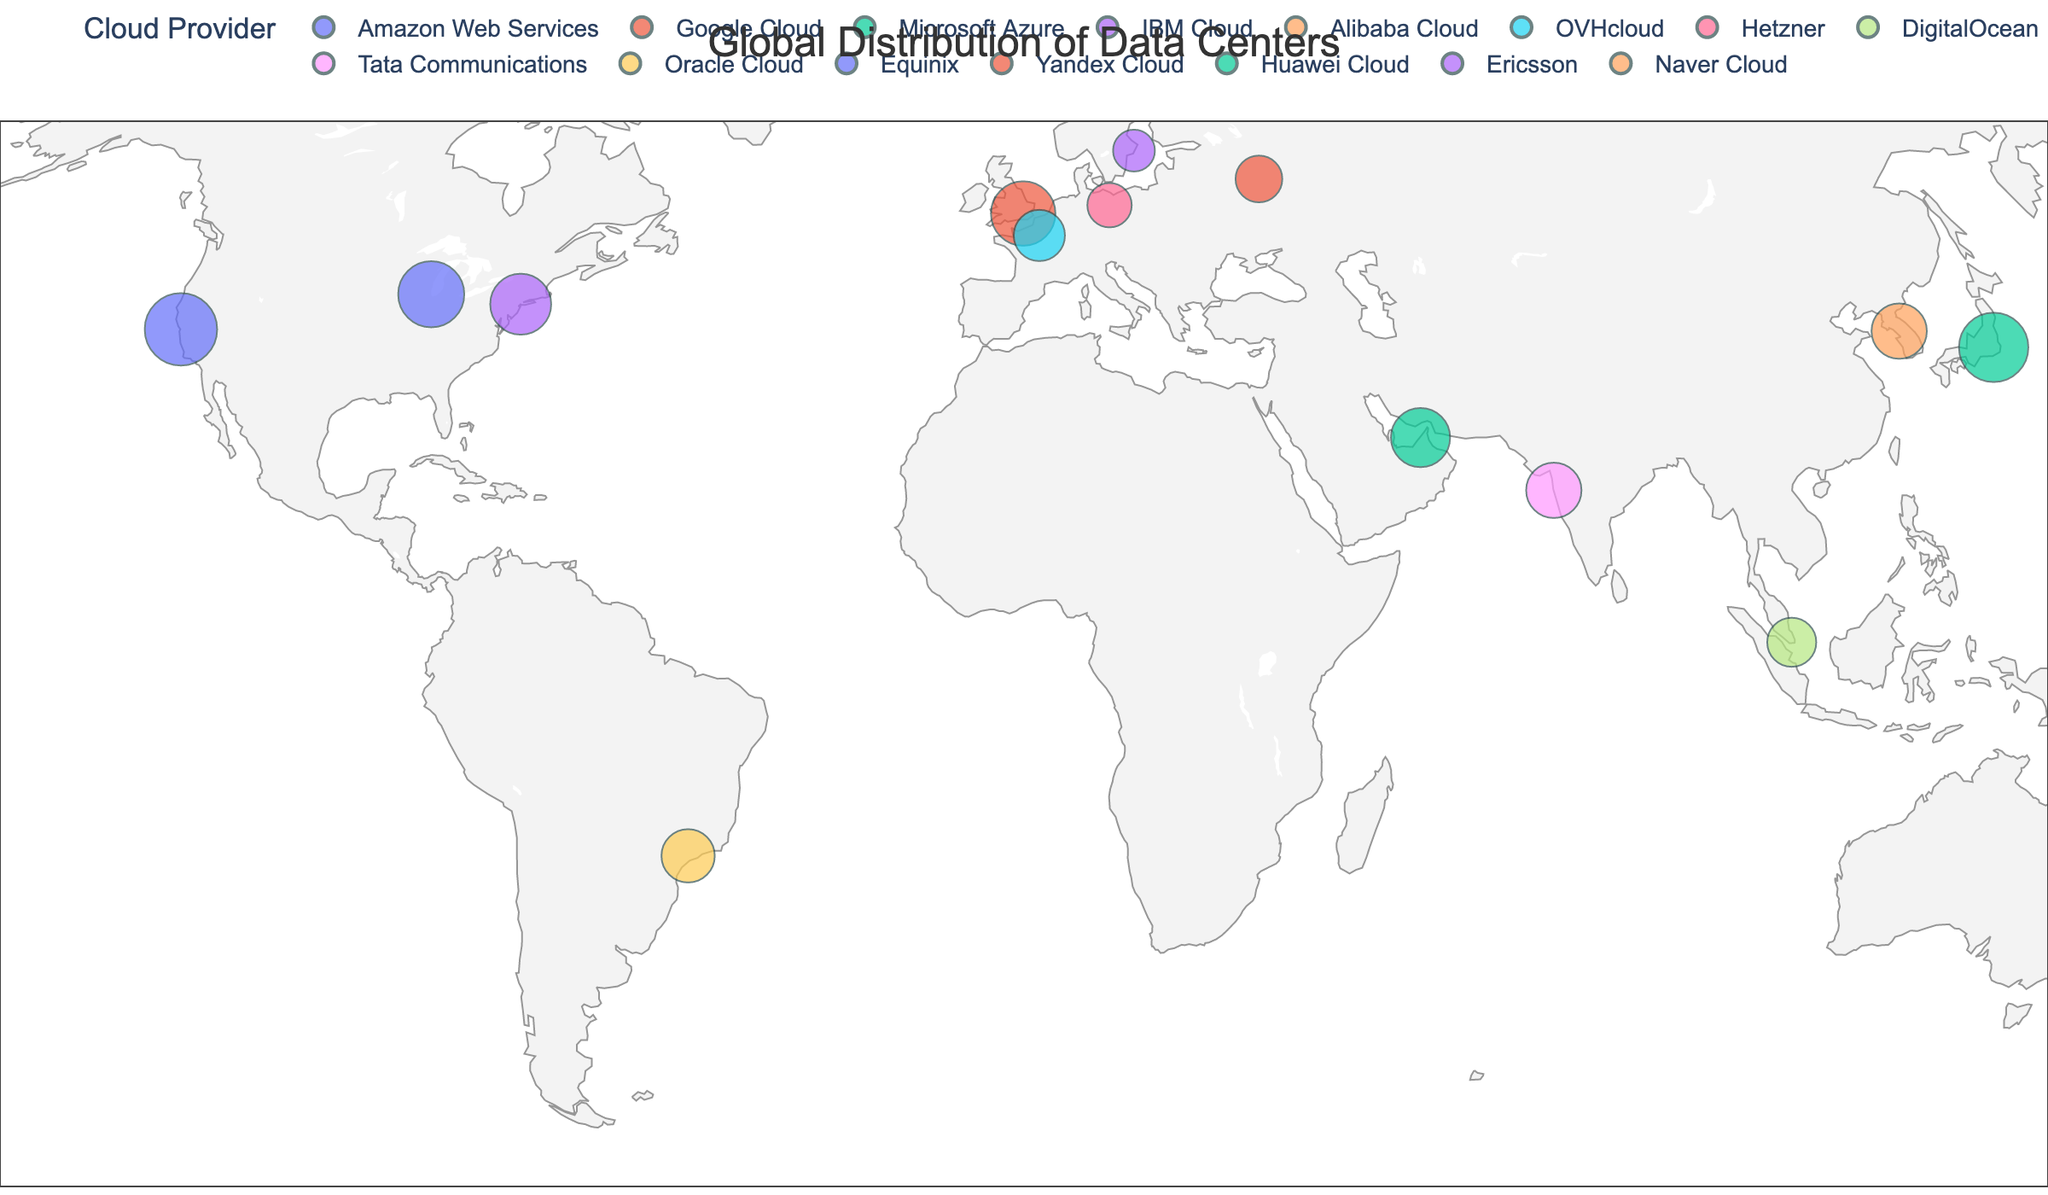What is the title of the figure? The title is usually located at the top center of the plot. In this case, the title in the configuration is explicitly set to "Global Distribution of Data Centers".
Answer: Global Distribution of Data Centers Which data center has the largest capacity in megawatts? By examining the data points sized by capacity, the largest data point corresponds to Amazon Web Services in San Francisco with a capacity of 120 MW.
Answer: Amazon Web Services in San Francisco How many cloud providers are represented in the figure? Each cloud provider is depicted by differing colors on the geographic scatter plot. By counting the unique providers listed, there are 15 providers.
Answer: 15 Which data center has the smallest number of servers? By looking at the hover information, the data point with the smallest number of servers is Ericsson in Stockholm with 55,000 servers.
Answer: Ericsson in Stockholm What is the total capacity in megawatts for data centers in the United States? There are two data centers in the United States: Amazon Web Services in San Francisco with 120 MW and Equinix in Chicago with 100 MW. Adding these together gives a total capacity of 220 MW.
Answer: 220 MW Which region has the highest concentration of data centers? By visually clustering the data points, it appears that Europe has the highest concentration of data centers, with multiple locations such as London, Paris, Berlin, and Stockholm.
Answer: Europe How does the size of the data center in São Paulo compare to the size of the data center in Dubai? The size of the data points represents capacity in megawatts. The Dubai data center by Huawei Cloud has 80 MW capacity, while the São Paulo data center by Oracle Cloud has 65 MW capacity, making the Dubai data center larger.
Answer: The Dubai data center is larger If we consider only the data centers with a capacity greater than 100 MW, how many are there, and which providers do they belong to? Checking the data points, the data centers with capacity greater than 100 MW include Amazon Web Services in San Francisco (120 MW), Microsoft Azure in Tokyo (110 MW), and Equinix in Chicago (100 MW). There are three such data centers.
Answer: 3 data centers: Amazon Web Services, Microsoft Azure, and Equinix What is the average number of servers for the providers located in Asia? The Asia locations are Tokyo (Microsoft Azure with 140,000 servers), Singapore (DigitalOcean with 70,000 servers), Mumbai (Tata Communications with 90,000 servers), Seoul (Naver Cloud with 90,000 servers), and Dubai (Huawei Cloud with 100,000 servers). Adding them: 140,000 + 70,000 + 90,000 + 90,000 + 100,000 = 490,000. Dividing by 5 gives an average of 98,000 servers.
Answer: 98,000 servers 